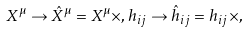<formula> <loc_0><loc_0><loc_500><loc_500>X ^ { \mu } \rightarrow \hat { X } ^ { \mu } = X ^ { \mu } \times , h _ { i j } \rightarrow \hat { h } _ { i j } = h _ { i j } \times ,</formula> 